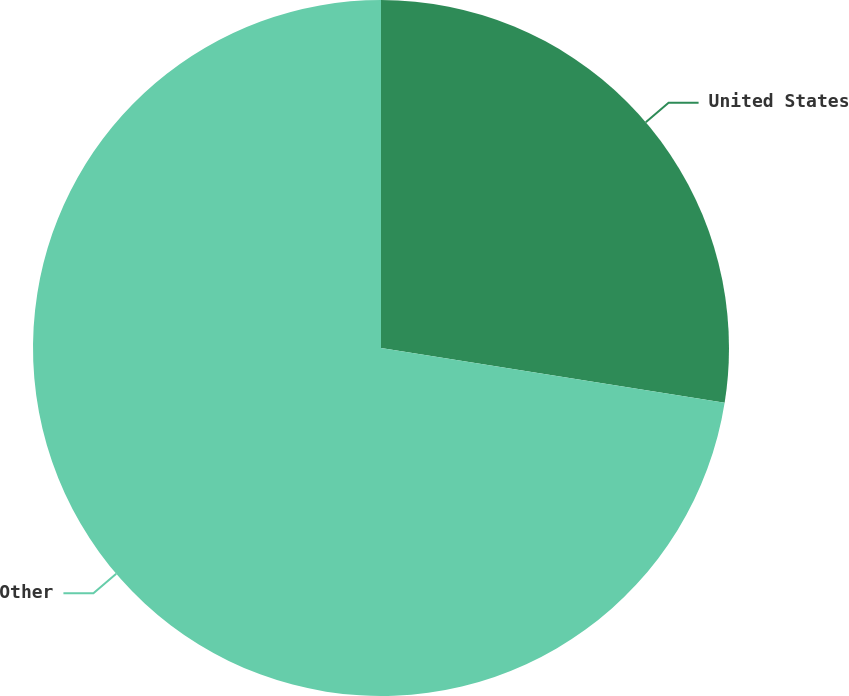Convert chart. <chart><loc_0><loc_0><loc_500><loc_500><pie_chart><fcel>United States<fcel>Other<nl><fcel>27.52%<fcel>72.48%<nl></chart> 